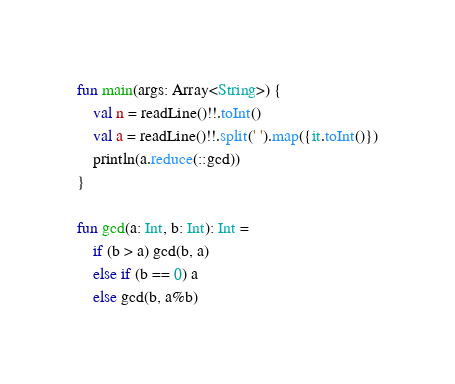<code> <loc_0><loc_0><loc_500><loc_500><_Kotlin_>
fun main(args: Array<String>) {
    val n = readLine()!!.toInt()
    val a = readLine()!!.split(' ').map({it.toInt()})
    println(a.reduce(::gcd))
}

fun gcd(a: Int, b: Int): Int =
    if (b > a) gcd(b, a)
    else if (b == 0) a
    else gcd(b, a%b)
</code> 